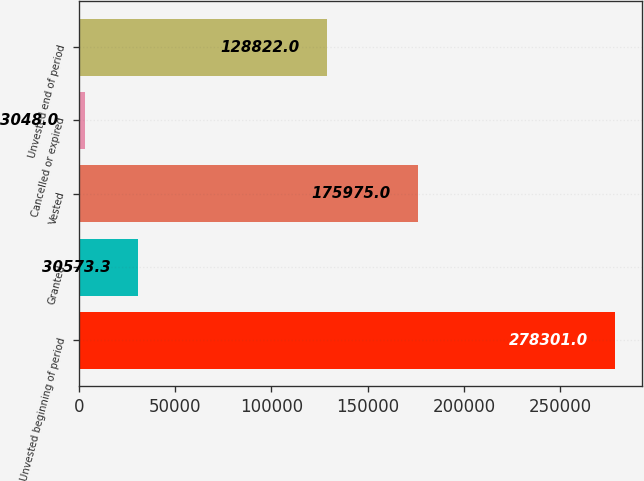Convert chart to OTSL. <chart><loc_0><loc_0><loc_500><loc_500><bar_chart><fcel>Unvested beginning of period<fcel>Granted<fcel>Vested<fcel>Cancelled or expired<fcel>Unvested end of period<nl><fcel>278301<fcel>30573.3<fcel>175975<fcel>3048<fcel>128822<nl></chart> 